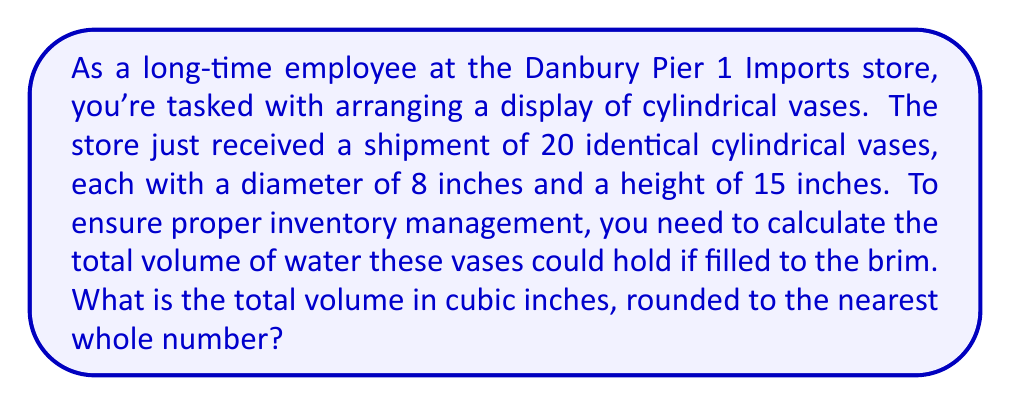Give your solution to this math problem. Let's approach this problem step-by-step:

1) First, we need to calculate the volume of a single cylindrical vase. The formula for the volume of a cylinder is:

   $$V = \pi r^2 h$$

   Where $r$ is the radius of the base and $h$ is the height of the cylinder.

2) We're given the diameter of 8 inches, so the radius is half of that:
   
   $$r = 8 \div 2 = 4\text{ inches}$$

3) The height is given as 15 inches.

4) Let's substitute these values into our formula:

   $$V = \pi (4\text{ in})^2 (15\text{ in})$$

5) Simplify:
   
   $$V = \pi (16\text{ in}^2) (15\text{ in}) = 240\pi\text{ in}^3$$

6) Using 3.14159 as an approximation for $\pi$:

   $$V \approx 240 \times 3.14159 \approx 753.98\text{ in}^3$$

7) This is the volume for one vase. Since we have 20 identical vases, we multiply this by 20:

   $$\text{Total Volume} = 753.98 \times 20 \approx 15,079.6\text{ in}^3$$

8) Rounding to the nearest whole number:

   $$\text{Total Volume} \approx 15,080\text{ cubic inches}$$
Answer: 15,080 cubic inches 